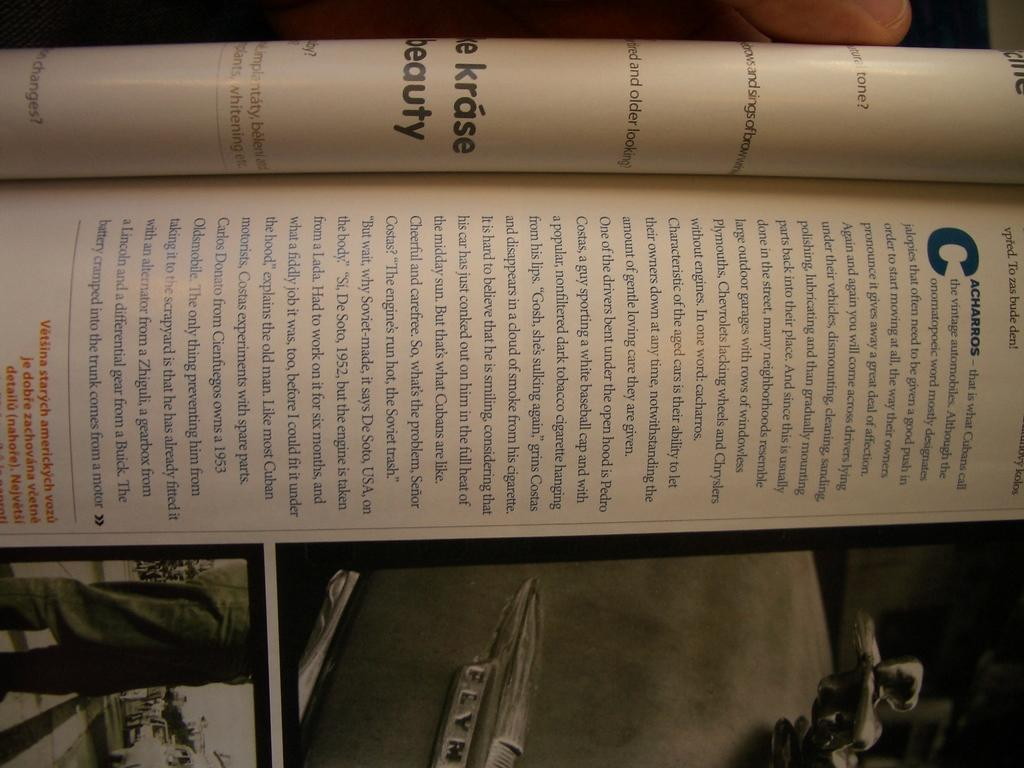<image>
Describe the image concisely. Book that is shown on automobiles in the cuban language which is Cacharros. 